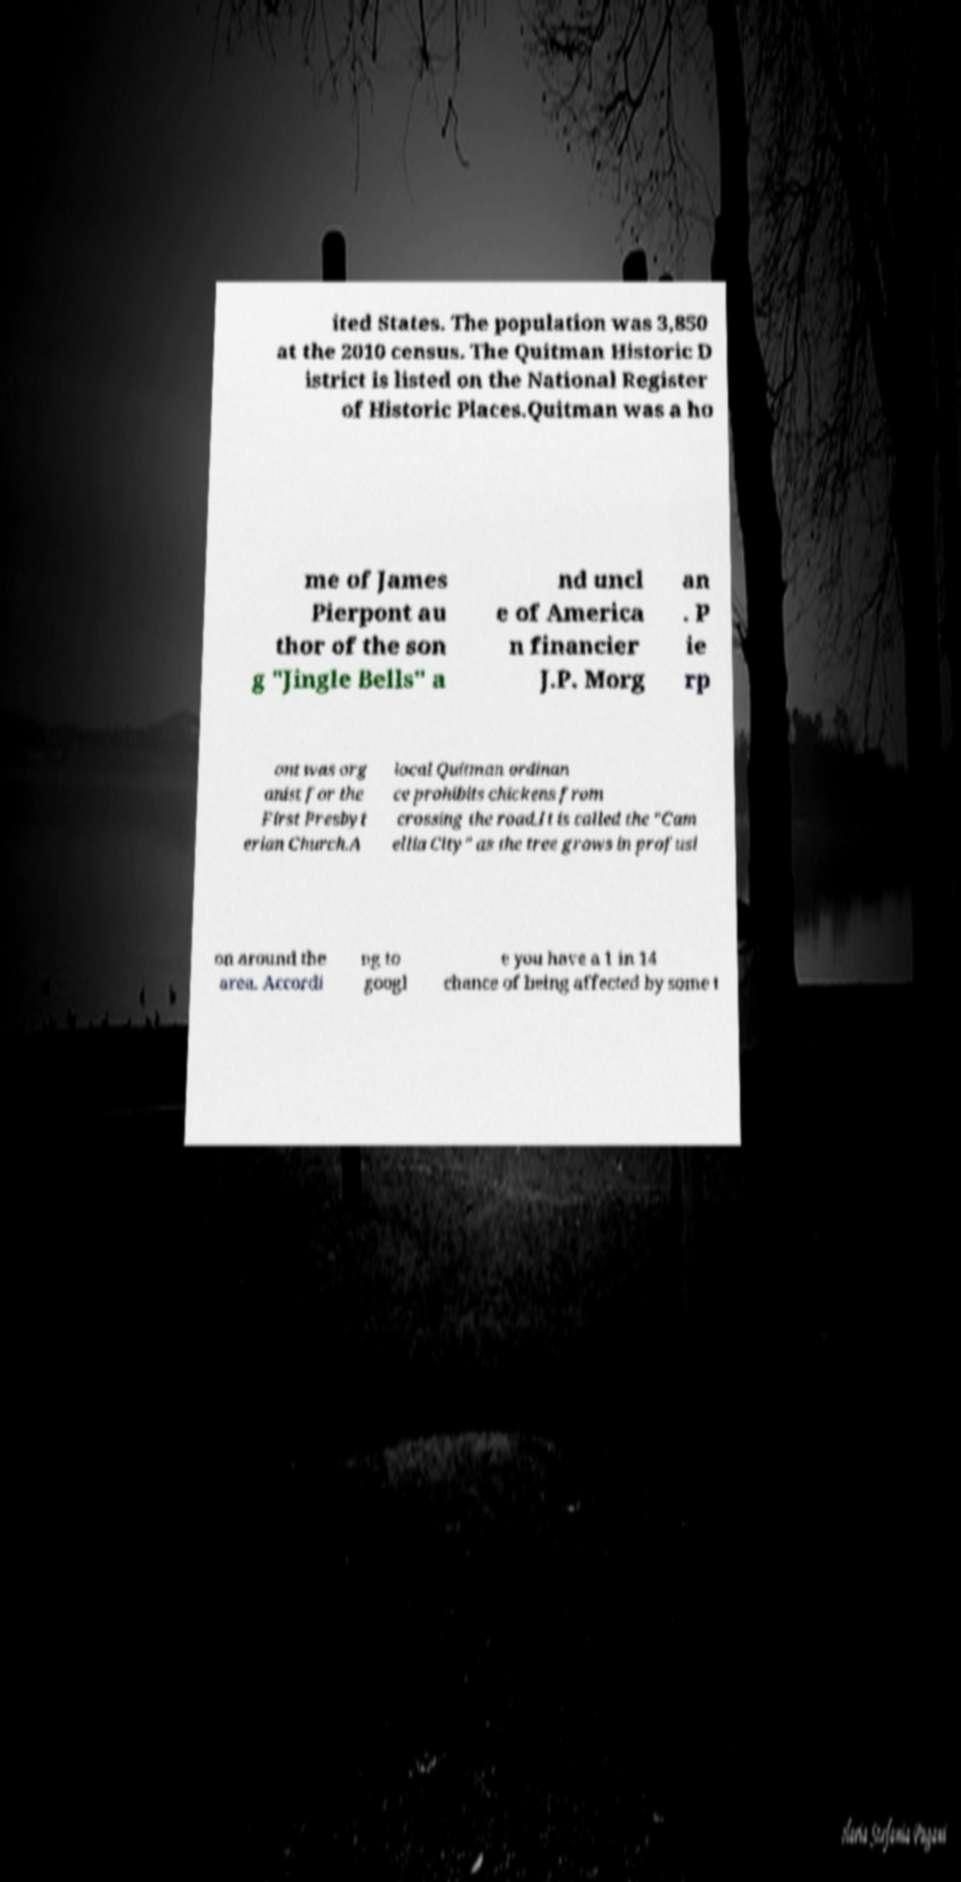Could you assist in decoding the text presented in this image and type it out clearly? ited States. The population was 3,850 at the 2010 census. The Quitman Historic D istrict is listed on the National Register of Historic Places.Quitman was a ho me of James Pierpont au thor of the son g "Jingle Bells" a nd uncl e of America n financier J.P. Morg an . P ie rp ont was org anist for the First Presbyt erian Church.A local Quitman ordinan ce prohibits chickens from crossing the road.It is called the "Cam ellia City" as the tree grows in profusi on around the area. Accordi ng to googl e you have a 1 in 14 chance of being affected by some t 